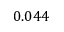<formula> <loc_0><loc_0><loc_500><loc_500>0 . 0 4 4</formula> 